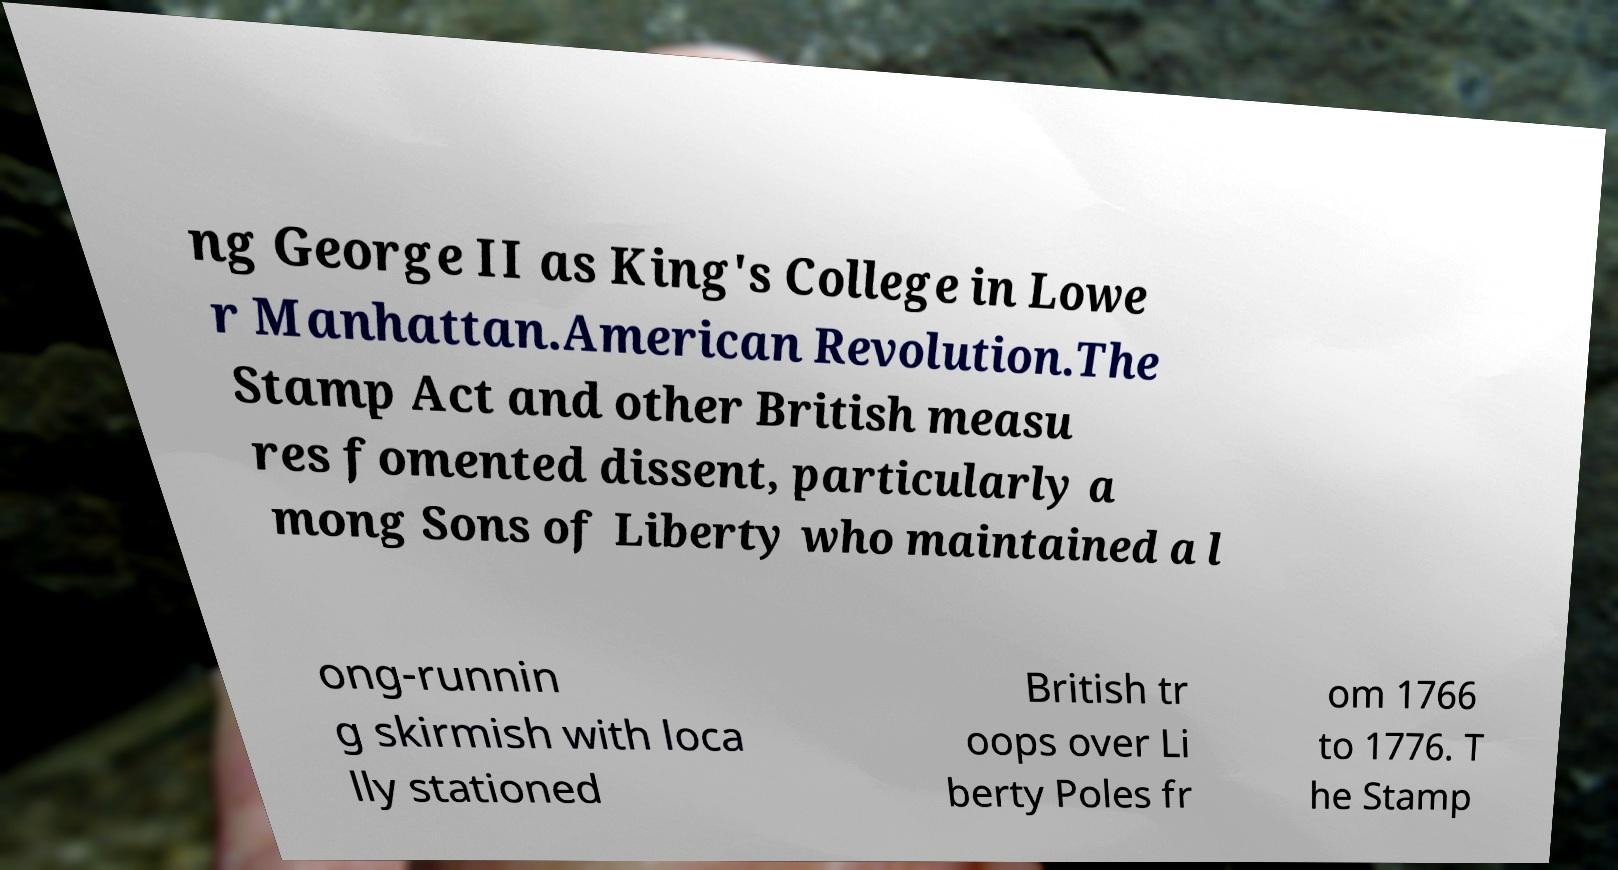I need the written content from this picture converted into text. Can you do that? ng George II as King's College in Lowe r Manhattan.American Revolution.The Stamp Act and other British measu res fomented dissent, particularly a mong Sons of Liberty who maintained a l ong-runnin g skirmish with loca lly stationed British tr oops over Li berty Poles fr om 1766 to 1776. T he Stamp 